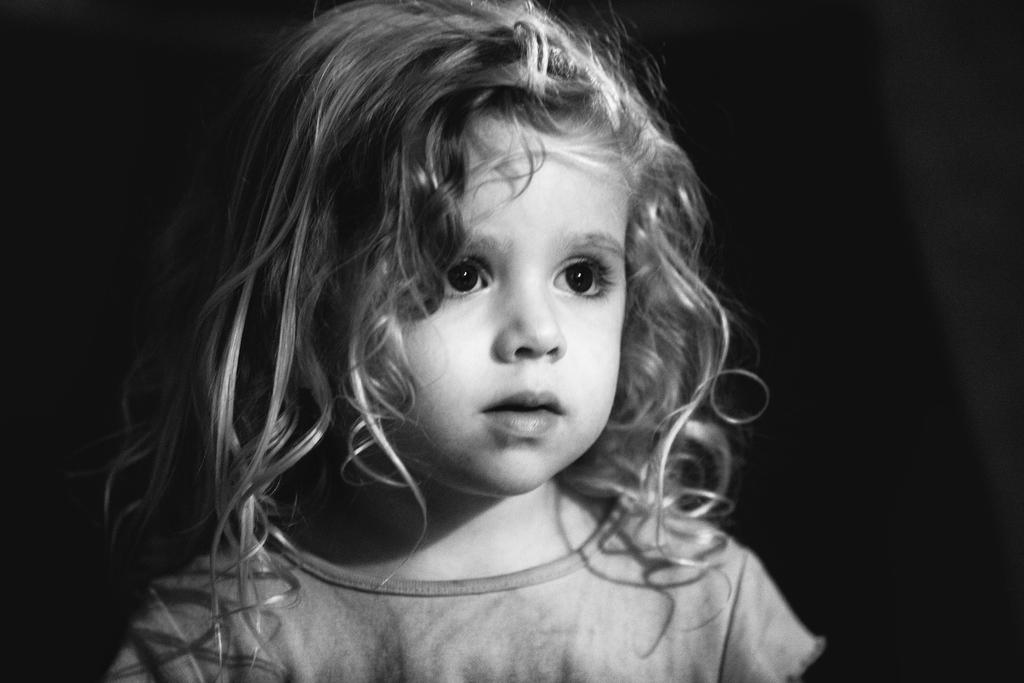What is the color scheme of the image? The image is black and white. What is the main subject of the image? There is a picture of a girl in the image. What is the girl wearing in the image? The girl is wearing a dress in the image. What type of alarm can be heard in the image? There is no alarm present in the image, as it is a black and white picture of a girl wearing a dress. What shape is the paper on which the girl's picture is drawn? There is no paper mentioned in the image, and it is not a drawing but a photograph. 